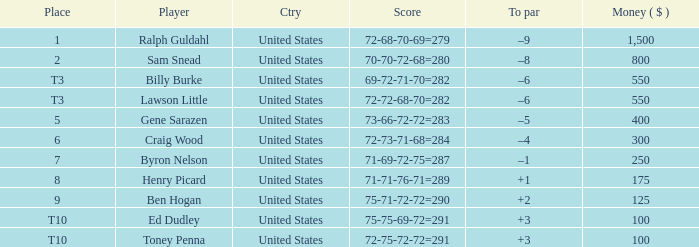Which score has a prize of $400? 73-66-72-72=283. 